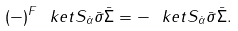Convert formula to latex. <formula><loc_0><loc_0><loc_500><loc_500>( - ) ^ { F } \ k e t { S _ { \dot { \alpha } } \bar { \sigma } \bar { \Sigma } } = - \ k e t { S _ { \dot { \alpha } } \bar { \sigma } \bar { \Sigma } } .</formula> 